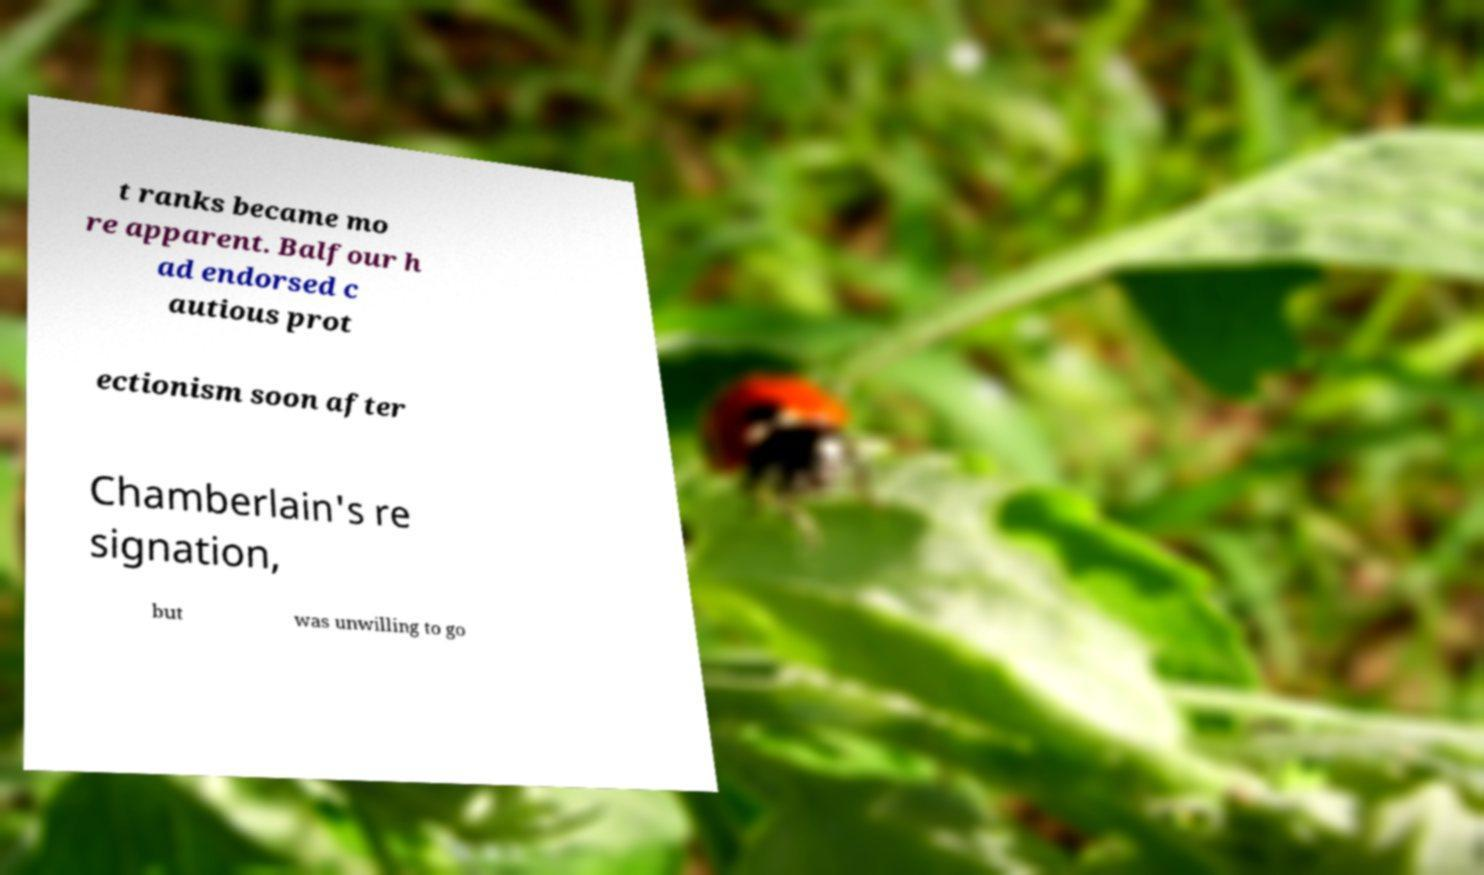What messages or text are displayed in this image? I need them in a readable, typed format. t ranks became mo re apparent. Balfour h ad endorsed c autious prot ectionism soon after Chamberlain's re signation, but was unwilling to go 